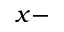<formula> <loc_0><loc_0><loc_500><loc_500>x -</formula> 